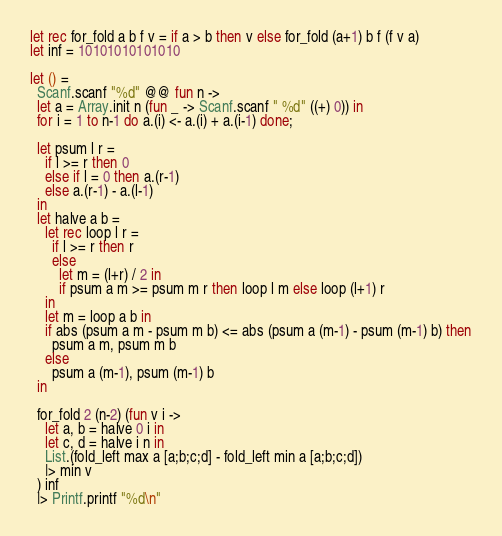Convert code to text. <code><loc_0><loc_0><loc_500><loc_500><_OCaml_>let rec for_fold a b f v = if a > b then v else for_fold (a+1) b f (f v a)
let inf = 10101010101010

let () =
  Scanf.scanf "%d" @@ fun n ->
  let a = Array.init n (fun _ -> Scanf.scanf " %d" ((+) 0)) in
  for i = 1 to n-1 do a.(i) <- a.(i) + a.(i-1) done;

  let psum l r =
    if l >= r then 0
    else if l = 0 then a.(r-1)
    else a.(r-1) - a.(l-1)
  in
  let halve a b =
    let rec loop l r =
      if l >= r then r
      else
        let m = (l+r) / 2 in
        if psum a m >= psum m r then loop l m else loop (l+1) r
    in
    let m = loop a b in
    if abs (psum a m - psum m b) <= abs (psum a (m-1) - psum (m-1) b) then
      psum a m, psum m b
    else
      psum a (m-1), psum (m-1) b
  in

  for_fold 2 (n-2) (fun v i ->
    let a, b = halve 0 i in
    let c, d = halve i n in
    List.(fold_left max a [a;b;c;d] - fold_left min a [a;b;c;d])
    |> min v
  ) inf
  |> Printf.printf "%d\n"
</code> 